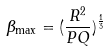<formula> <loc_0><loc_0><loc_500><loc_500>\beta _ { \max } = ( \frac { R ^ { 2 } } { P Q } ) ^ { \frac { 1 } { 3 } }</formula> 